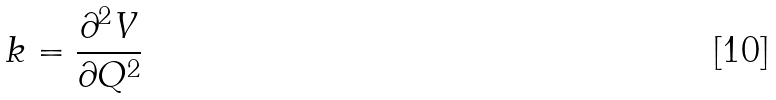Convert formula to latex. <formula><loc_0><loc_0><loc_500><loc_500>k = \frac { \partial ^ { 2 } V } { \partial Q ^ { 2 } }</formula> 